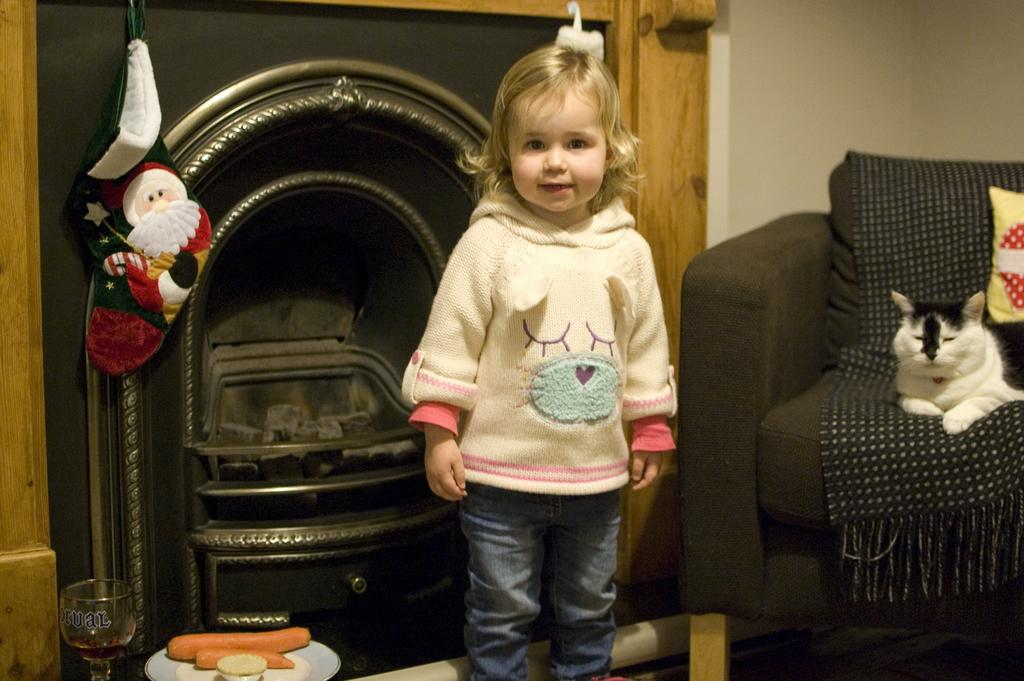What is the main subject of the image? There is a girl standing in the image. What objects are present in the image? There is a chair, a pillow, a cat, a glass, carrots in a plate, and a bowl in the image. What type of cannon is being used by the girl's partner in the image? There is no cannon or partner present in the image. Is the girl playing baseball with her partner in the image? There is no baseball or partner present in the image. 